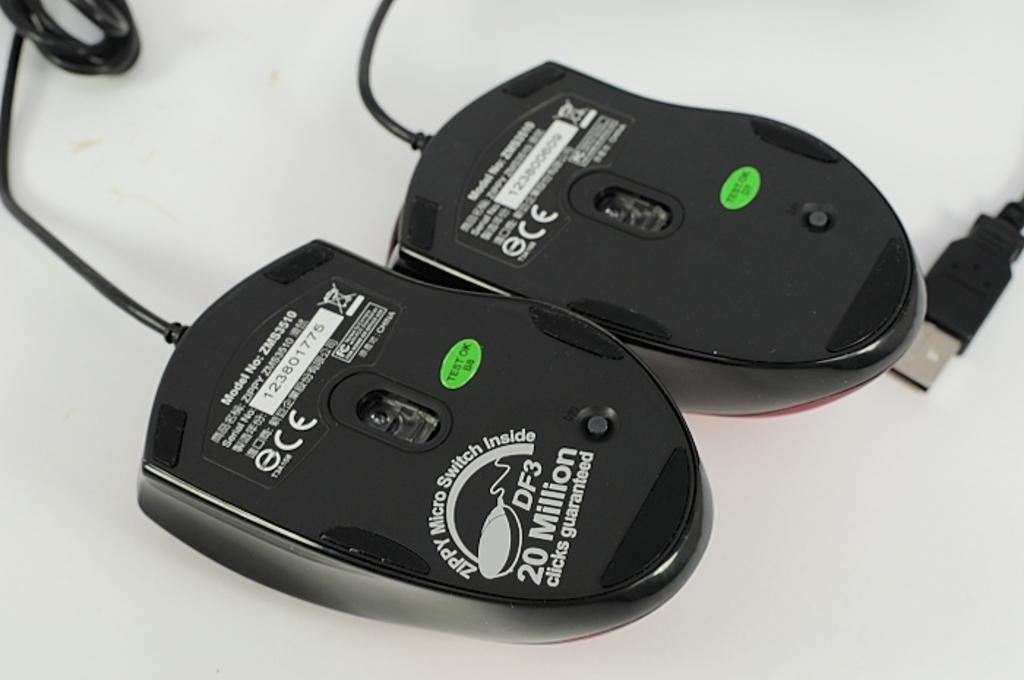<image>
Share a concise interpretation of the image provided. 2 Computer Mouses with a green label saying Test OK B8. 